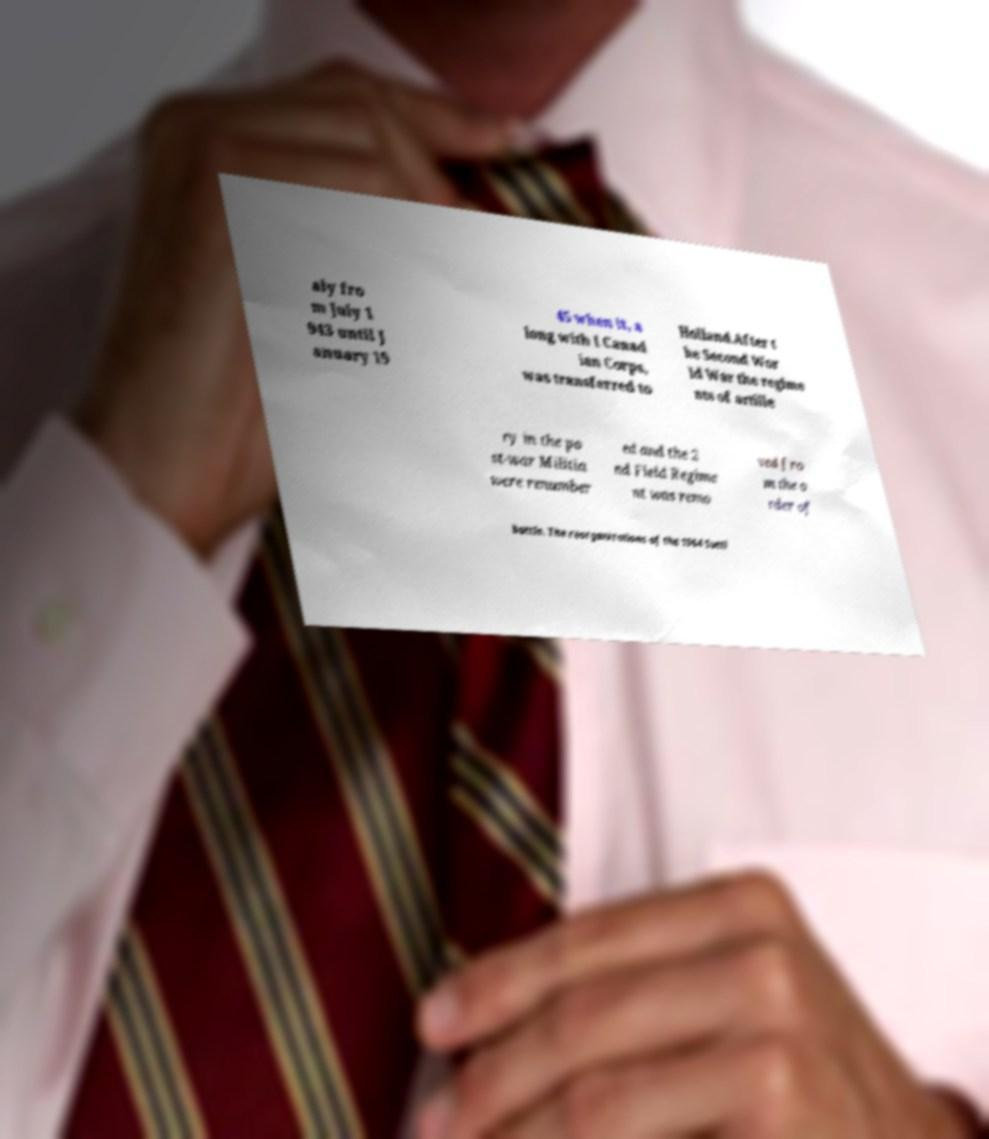Please read and relay the text visible in this image. What does it say? aly fro m July 1 943 until J anuary 19 45 when it, a long with I Canad ian Corps, was transferred to Holland.After t he Second Wor ld War the regime nts of artille ry in the po st-war Militia were renumber ed and the 2 nd Field Regime nt was remo ved fro m the o rder of battle. The reorganizations of the 1964 Sutti 